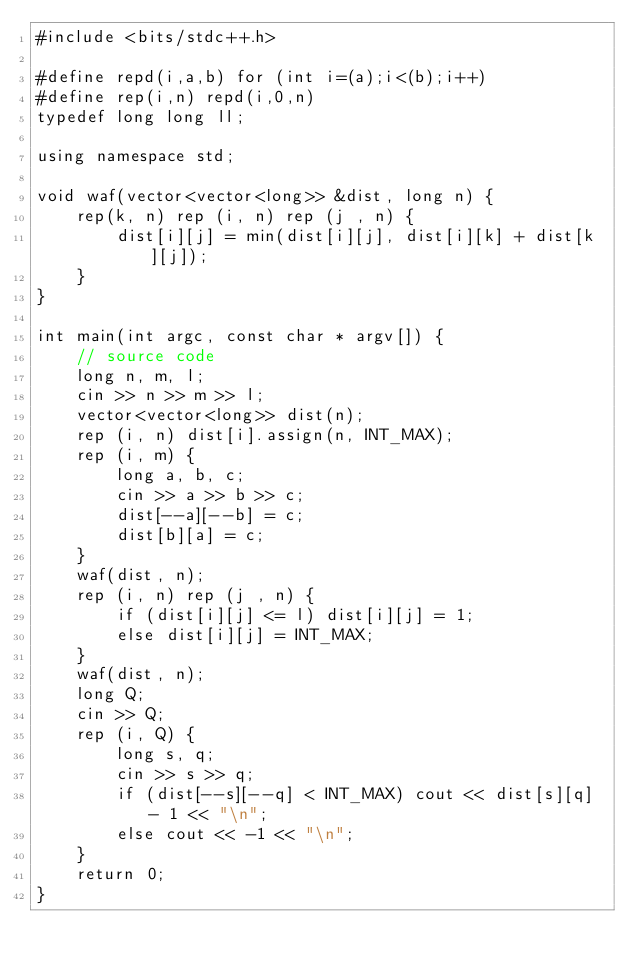<code> <loc_0><loc_0><loc_500><loc_500><_C++_>#include <bits/stdc++.h>

#define repd(i,a,b) for (int i=(a);i<(b);i++)
#define rep(i,n) repd(i,0,n)
typedef long long ll;

using namespace std;

void waf(vector<vector<long>> &dist, long n) {
    rep(k, n) rep (i, n) rep (j , n) {
        dist[i][j] = min(dist[i][j], dist[i][k] + dist[k][j]);
    }
}

int main(int argc, const char * argv[]) {
    // source code
    long n, m, l;
    cin >> n >> m >> l;
    vector<vector<long>> dist(n);
    rep (i, n) dist[i].assign(n, INT_MAX);
    rep (i, m) {
        long a, b, c;
        cin >> a >> b >> c;
        dist[--a][--b] = c;
        dist[b][a] = c;
    }
    waf(dist, n);
    rep (i, n) rep (j , n) {
        if (dist[i][j] <= l) dist[i][j] = 1;
        else dist[i][j] = INT_MAX;
    }
    waf(dist, n);
    long Q;
    cin >> Q;
    rep (i, Q) {
        long s, q;
        cin >> s >> q;
        if (dist[--s][--q] < INT_MAX) cout << dist[s][q] - 1 << "\n";
        else cout << -1 << "\n";
    }
    return 0;
}
</code> 